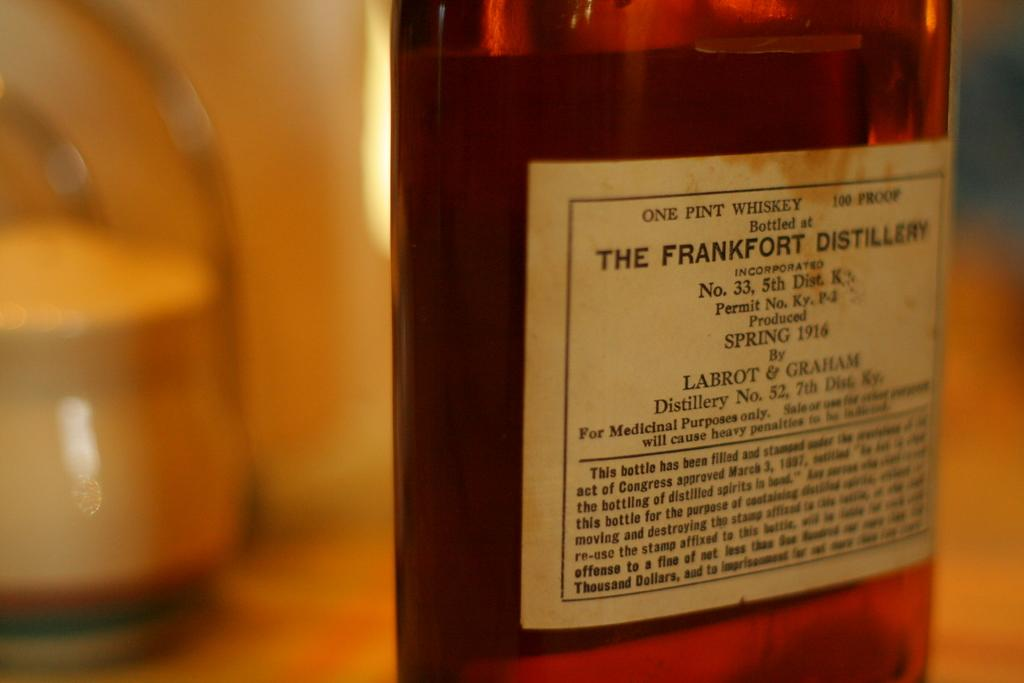<image>
Render a clear and concise summary of the photo. One pint of whiskey from the Frankfurt Distillery that was produced in Spring 1916 is pictured. 